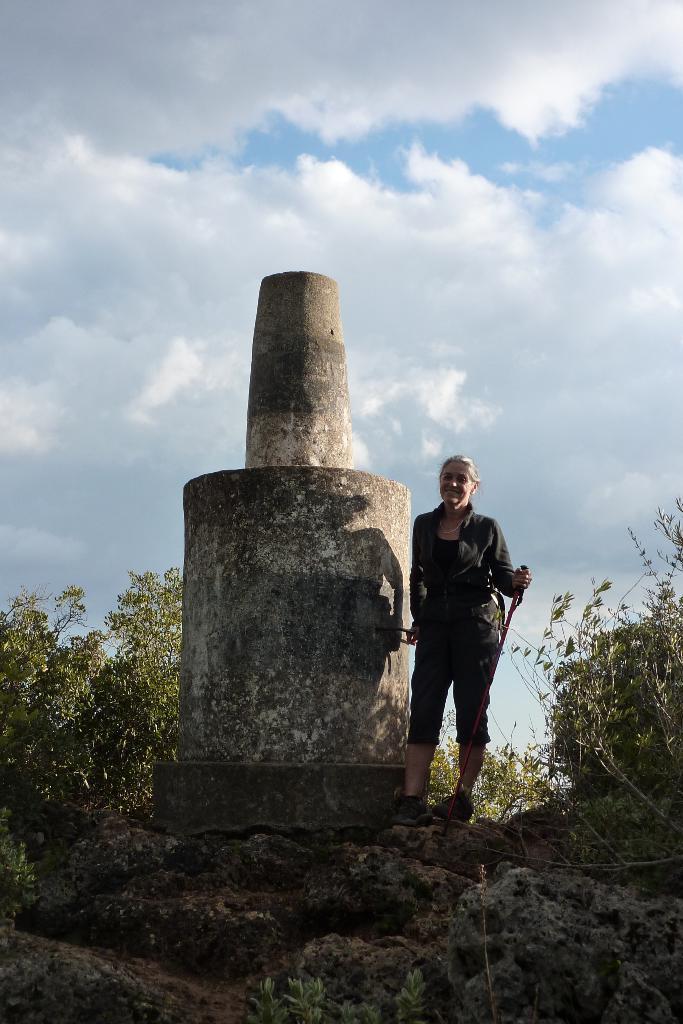Could you give a brief overview of what you see in this image? In the image there is a woman in black dress standing beside a statue with plants on either side of it and its sky with clouds. 